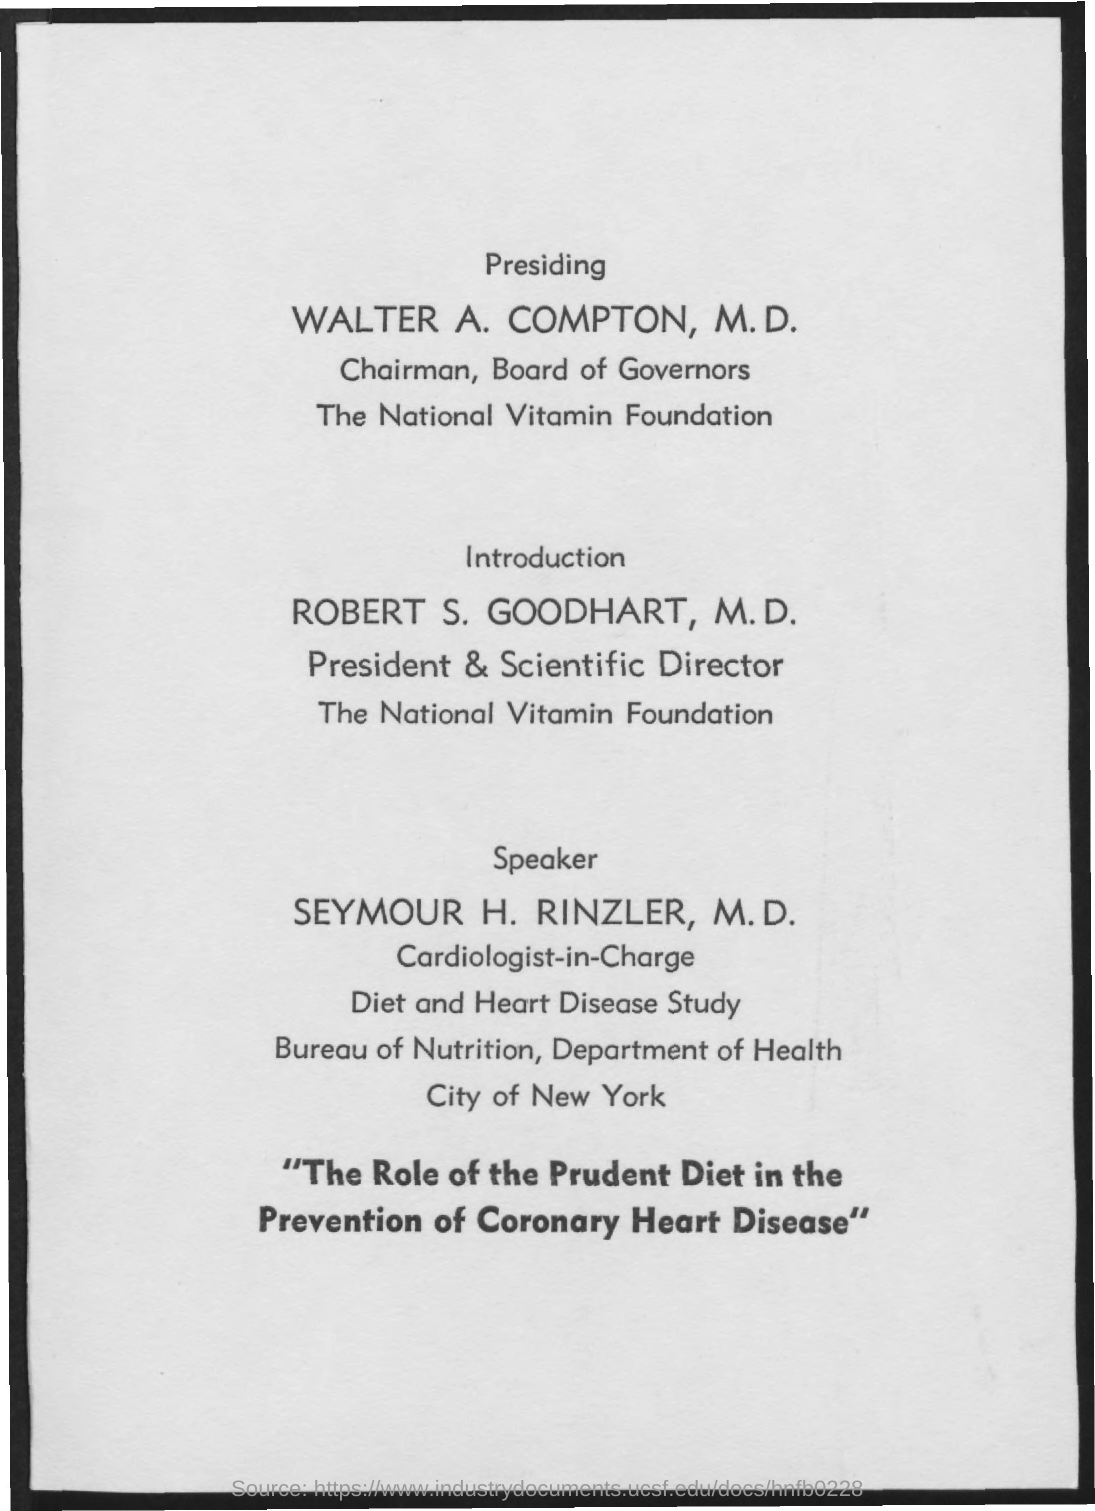Who is the President & Scientific Director of National Vitamin Foundation?
Your answer should be very brief. Robert s. goodhart, m.d. 